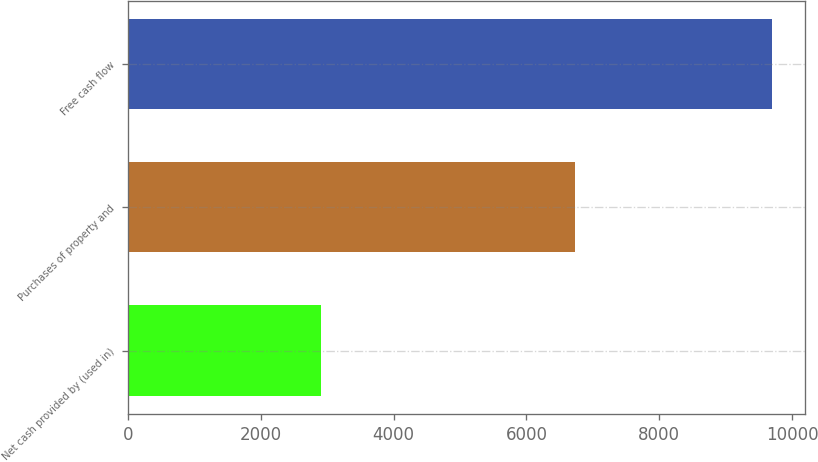Convert chart. <chart><loc_0><loc_0><loc_500><loc_500><bar_chart><fcel>Net cash provided by (used in)<fcel>Purchases of property and<fcel>Free cash flow<nl><fcel>2911<fcel>6737<fcel>9706<nl></chart> 